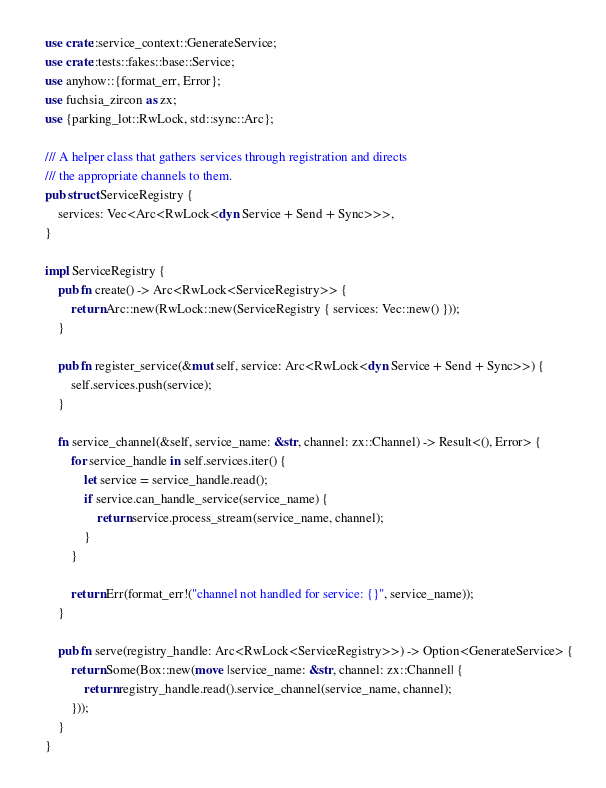<code> <loc_0><loc_0><loc_500><loc_500><_Rust_>use crate::service_context::GenerateService;
use crate::tests::fakes::base::Service;
use anyhow::{format_err, Error};
use fuchsia_zircon as zx;
use {parking_lot::RwLock, std::sync::Arc};

/// A helper class that gathers services through registration and directs
/// the appropriate channels to them.
pub struct ServiceRegistry {
    services: Vec<Arc<RwLock<dyn Service + Send + Sync>>>,
}

impl ServiceRegistry {
    pub fn create() -> Arc<RwLock<ServiceRegistry>> {
        return Arc::new(RwLock::new(ServiceRegistry { services: Vec::new() }));
    }

    pub fn register_service(&mut self, service: Arc<RwLock<dyn Service + Send + Sync>>) {
        self.services.push(service);
    }

    fn service_channel(&self, service_name: &str, channel: zx::Channel) -> Result<(), Error> {
        for service_handle in self.services.iter() {
            let service = service_handle.read();
            if service.can_handle_service(service_name) {
                return service.process_stream(service_name, channel);
            }
        }

        return Err(format_err!("channel not handled for service: {}", service_name));
    }

    pub fn serve(registry_handle: Arc<RwLock<ServiceRegistry>>) -> Option<GenerateService> {
        return Some(Box::new(move |service_name: &str, channel: zx::Channel| {
            return registry_handle.read().service_channel(service_name, channel);
        }));
    }
}
</code> 